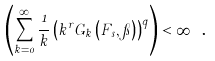Convert formula to latex. <formula><loc_0><loc_0><loc_500><loc_500>\left ( \sum _ { k = 0 } ^ { \infty } \frac { 1 } { k } \left ( k ^ { r } G _ { k } \left ( F _ { s } , \pi \right ) \right ) ^ { q } \right ) < \infty \text { .}</formula> 